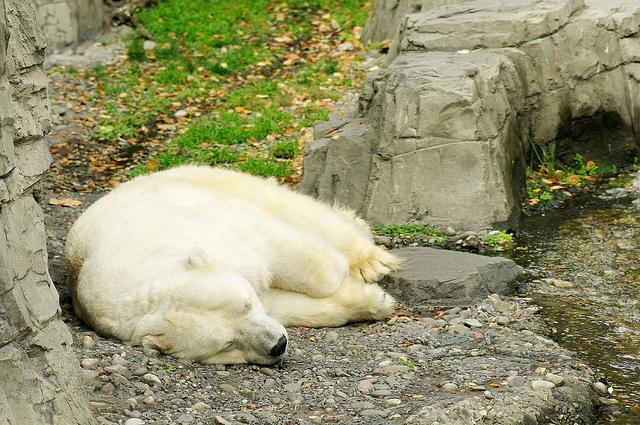Is it daytime?
Keep it brief. Yes. What is the polar bear doing?
Quick response, please. Sleeping. Where is the Polar bear at?
Give a very brief answer. Zoo. 